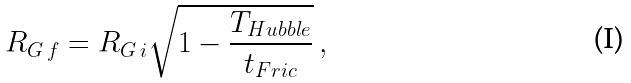<formula> <loc_0><loc_0><loc_500><loc_500>R _ { G \, f } = R _ { G \, i } \sqrt { 1 - \frac { T _ { H u b b l e } } { t _ { F r i c } } } \, ,</formula> 